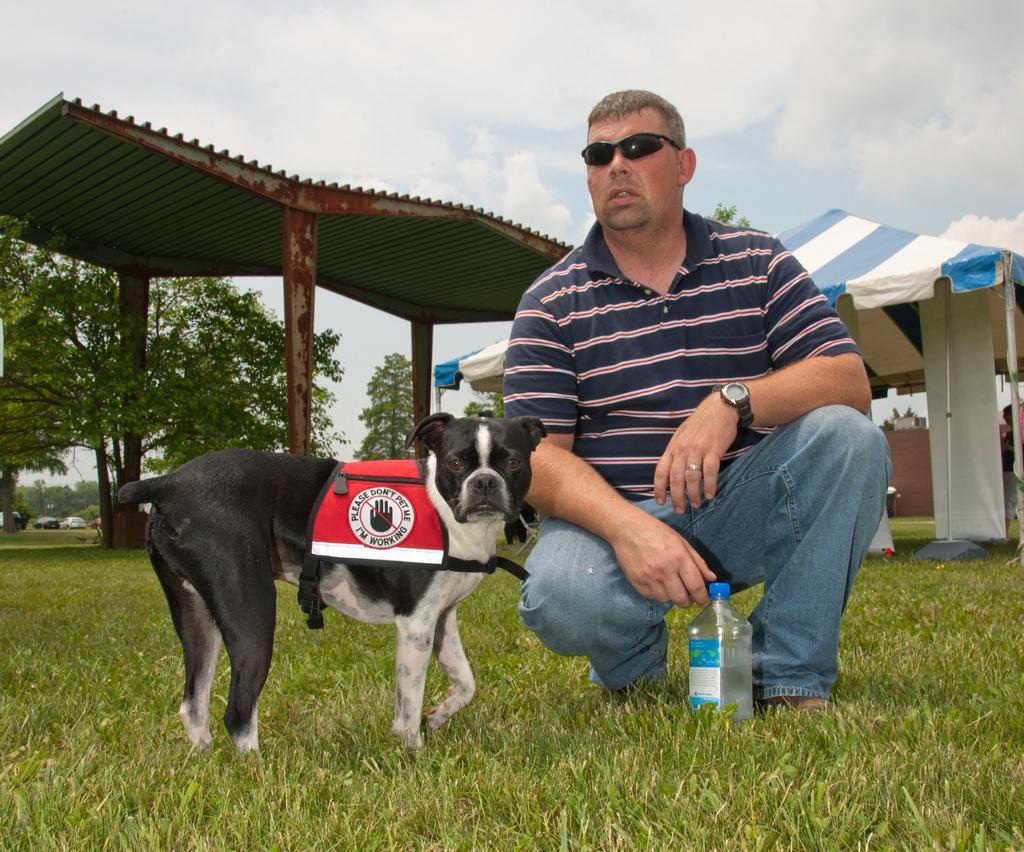In one or two sentences, can you explain what this image depicts? In this image i can see a man and a dog in front of a man there is a bottle at the background i can see a shed, tree and a sky. 